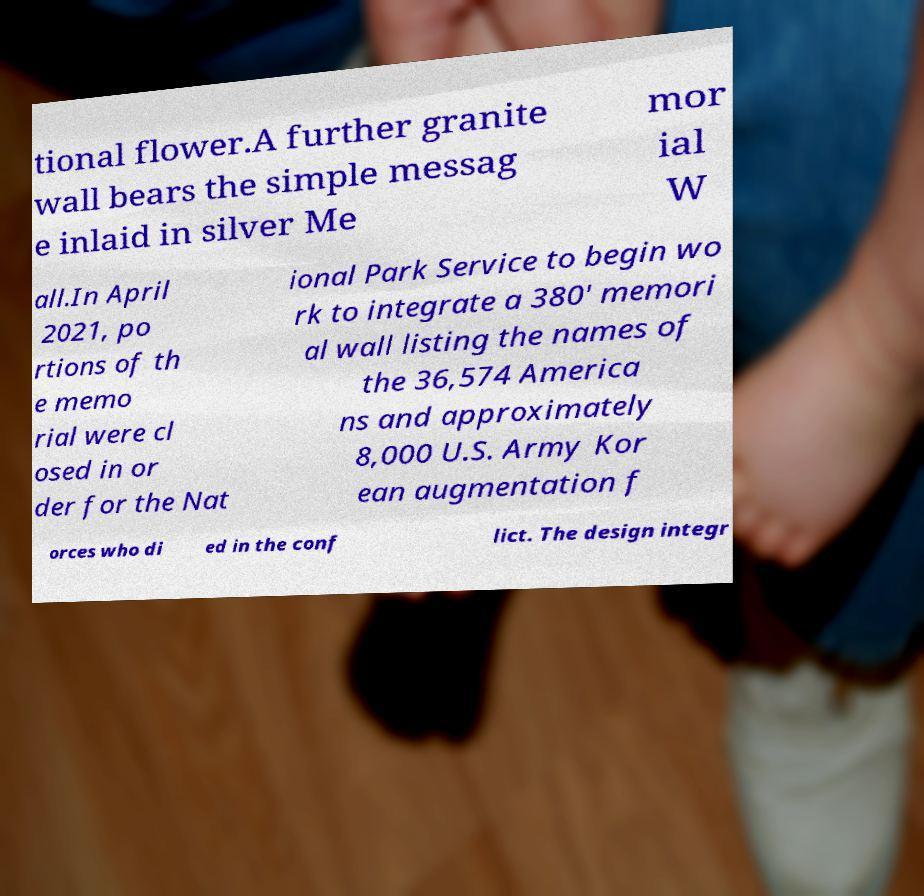Could you extract and type out the text from this image? tional flower.A further granite wall bears the simple messag e inlaid in silver Me mor ial W all.In April 2021, po rtions of th e memo rial were cl osed in or der for the Nat ional Park Service to begin wo rk to integrate a 380′ memori al wall listing the names of the 36,574 America ns and approximately 8,000 U.S. Army Kor ean augmentation f orces who di ed in the conf lict. The design integr 